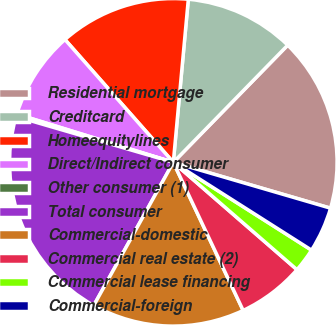Convert chart to OTSL. <chart><loc_0><loc_0><loc_500><loc_500><pie_chart><fcel>Residential mortgage<fcel>Creditcard<fcel>Homeequitylines<fcel>Direct/Indirect consumer<fcel>Other consumer (1)<fcel>Total consumer<fcel>Commercial-domestic<fcel>Commercial real estate (2)<fcel>Commercial lease financing<fcel>Commercial-foreign<nl><fcel>17.21%<fcel>10.85%<fcel>12.97%<fcel>8.73%<fcel>0.25%<fcel>21.44%<fcel>15.09%<fcel>6.61%<fcel>2.37%<fcel>4.49%<nl></chart> 